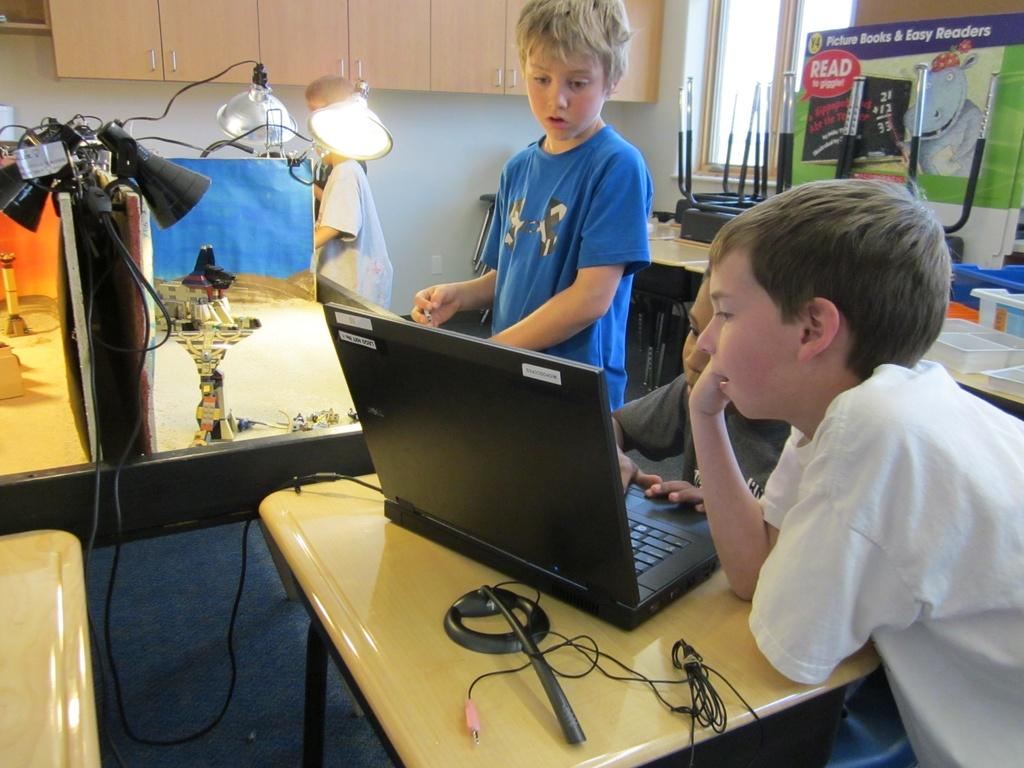<image>
Present a compact description of the photo's key features. Some children sit in front of a poster that says "read to giggle". 